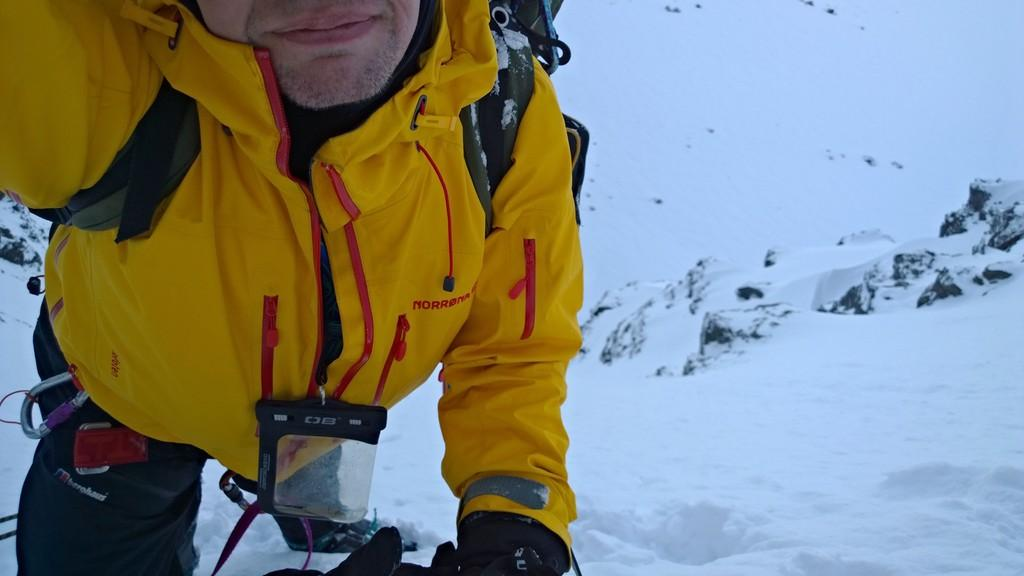Who is present in the image? There is a man in the image. What is the man wearing? The man is wearing a yellow jacket. What is the man carrying? The man is carrying a backpack. What is the ground covered with in the image? There is snow at the bottom of the image. What type of pet can be seen in the image? There is no pet present in the image. What kind of structure is visible in the background of the image? There is no structure visible in the background of the image. 